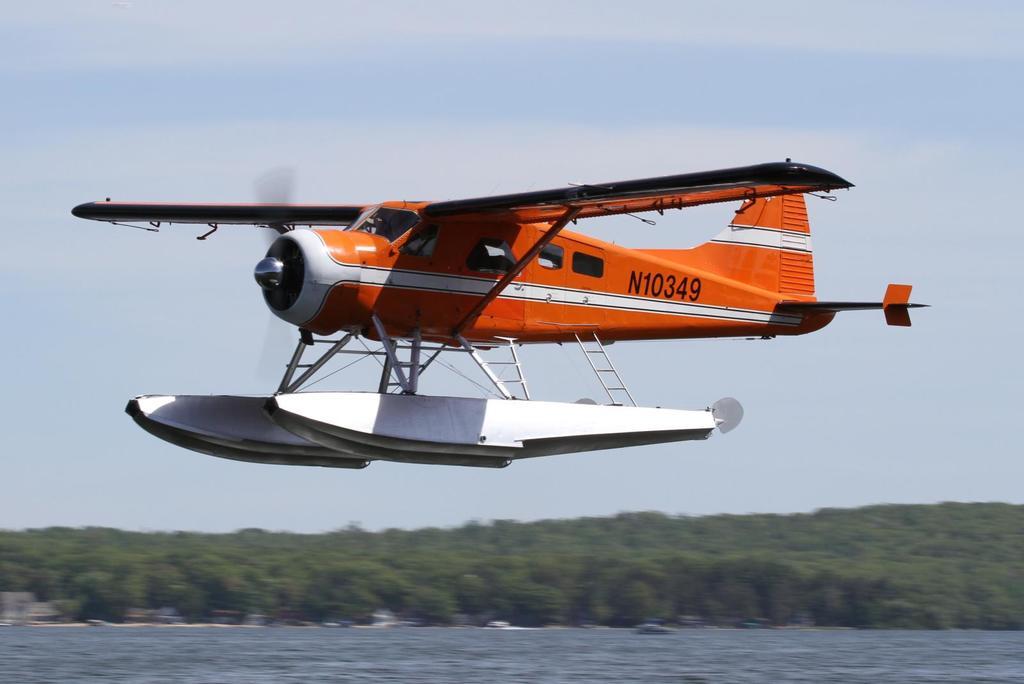What is the identification number of the plane?
Your response must be concise. N10349. 